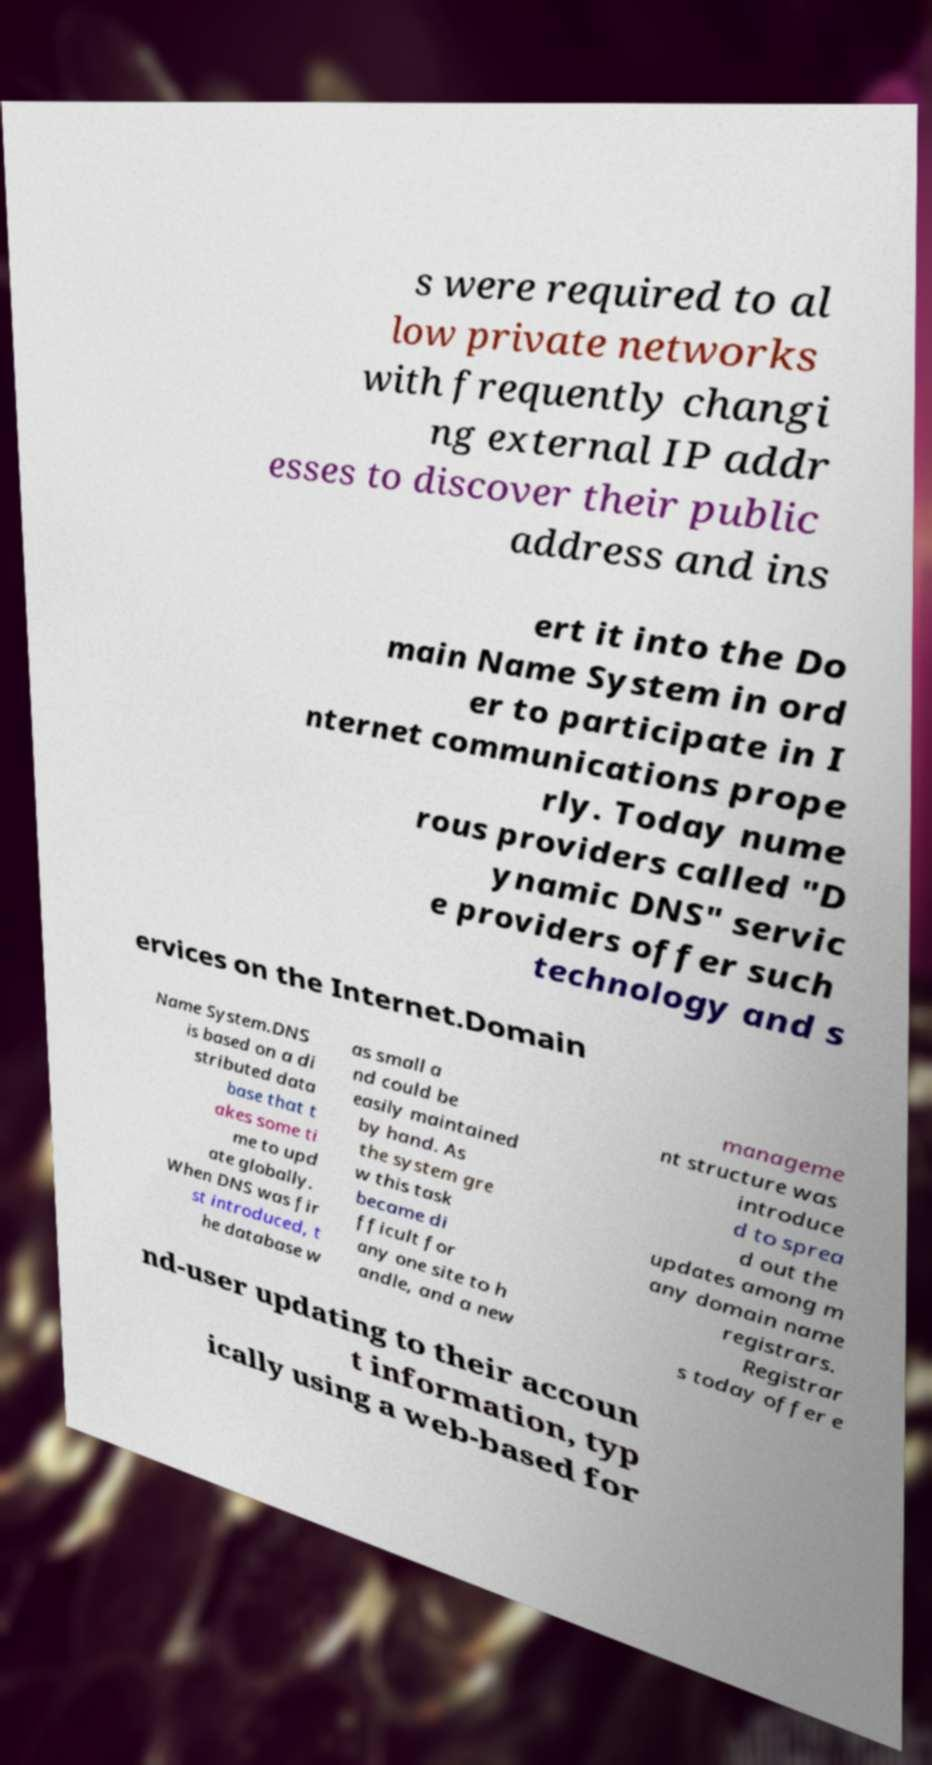Please read and relay the text visible in this image. What does it say? s were required to al low private networks with frequently changi ng external IP addr esses to discover their public address and ins ert it into the Do main Name System in ord er to participate in I nternet communications prope rly. Today nume rous providers called "D ynamic DNS" servic e providers offer such technology and s ervices on the Internet.Domain Name System.DNS is based on a di stributed data base that t akes some ti me to upd ate globally. When DNS was fir st introduced, t he database w as small a nd could be easily maintained by hand. As the system gre w this task became di fficult for any one site to h andle, and a new manageme nt structure was introduce d to sprea d out the updates among m any domain name registrars. Registrar s today offer e nd-user updating to their accoun t information, typ ically using a web-based for 